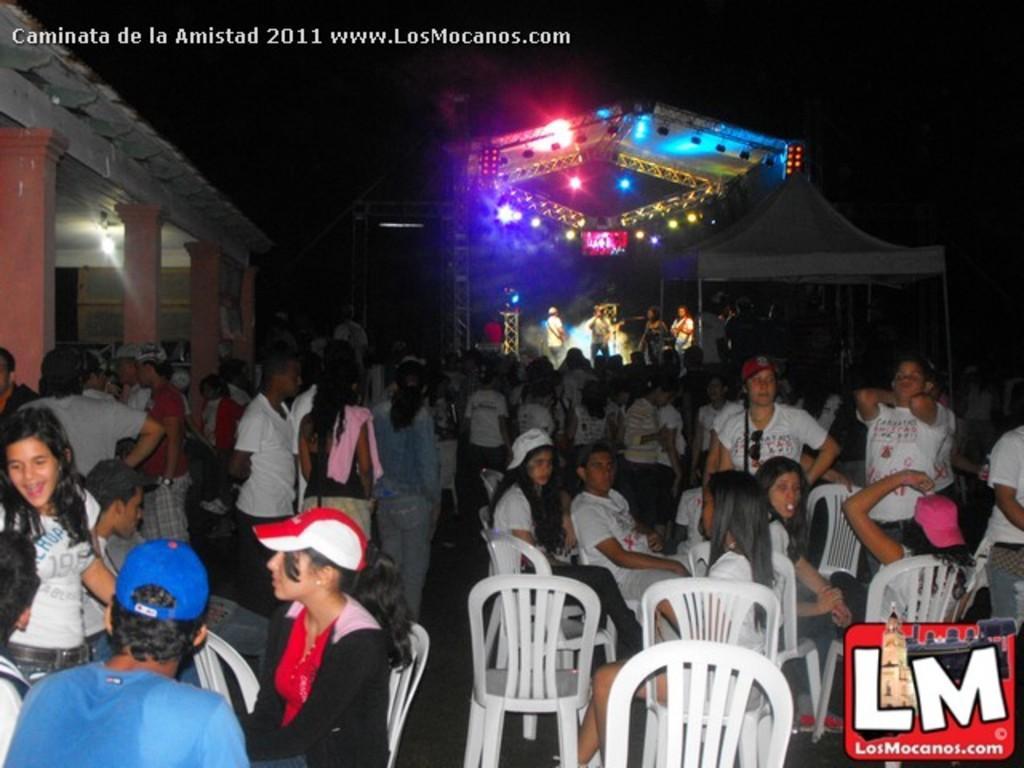Describe this image in one or two sentences. In this image there are group of persons who are sitting on the chairs and standing on the floor and at the background of the image there are group of persons who are playing musical instruments under the lights. 